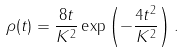<formula> <loc_0><loc_0><loc_500><loc_500>\rho ( t ) = \frac { 8 t } { K ^ { 2 } } \exp \left ( - \frac { 4 t ^ { 2 } } { K ^ { 2 } } \right ) .</formula> 